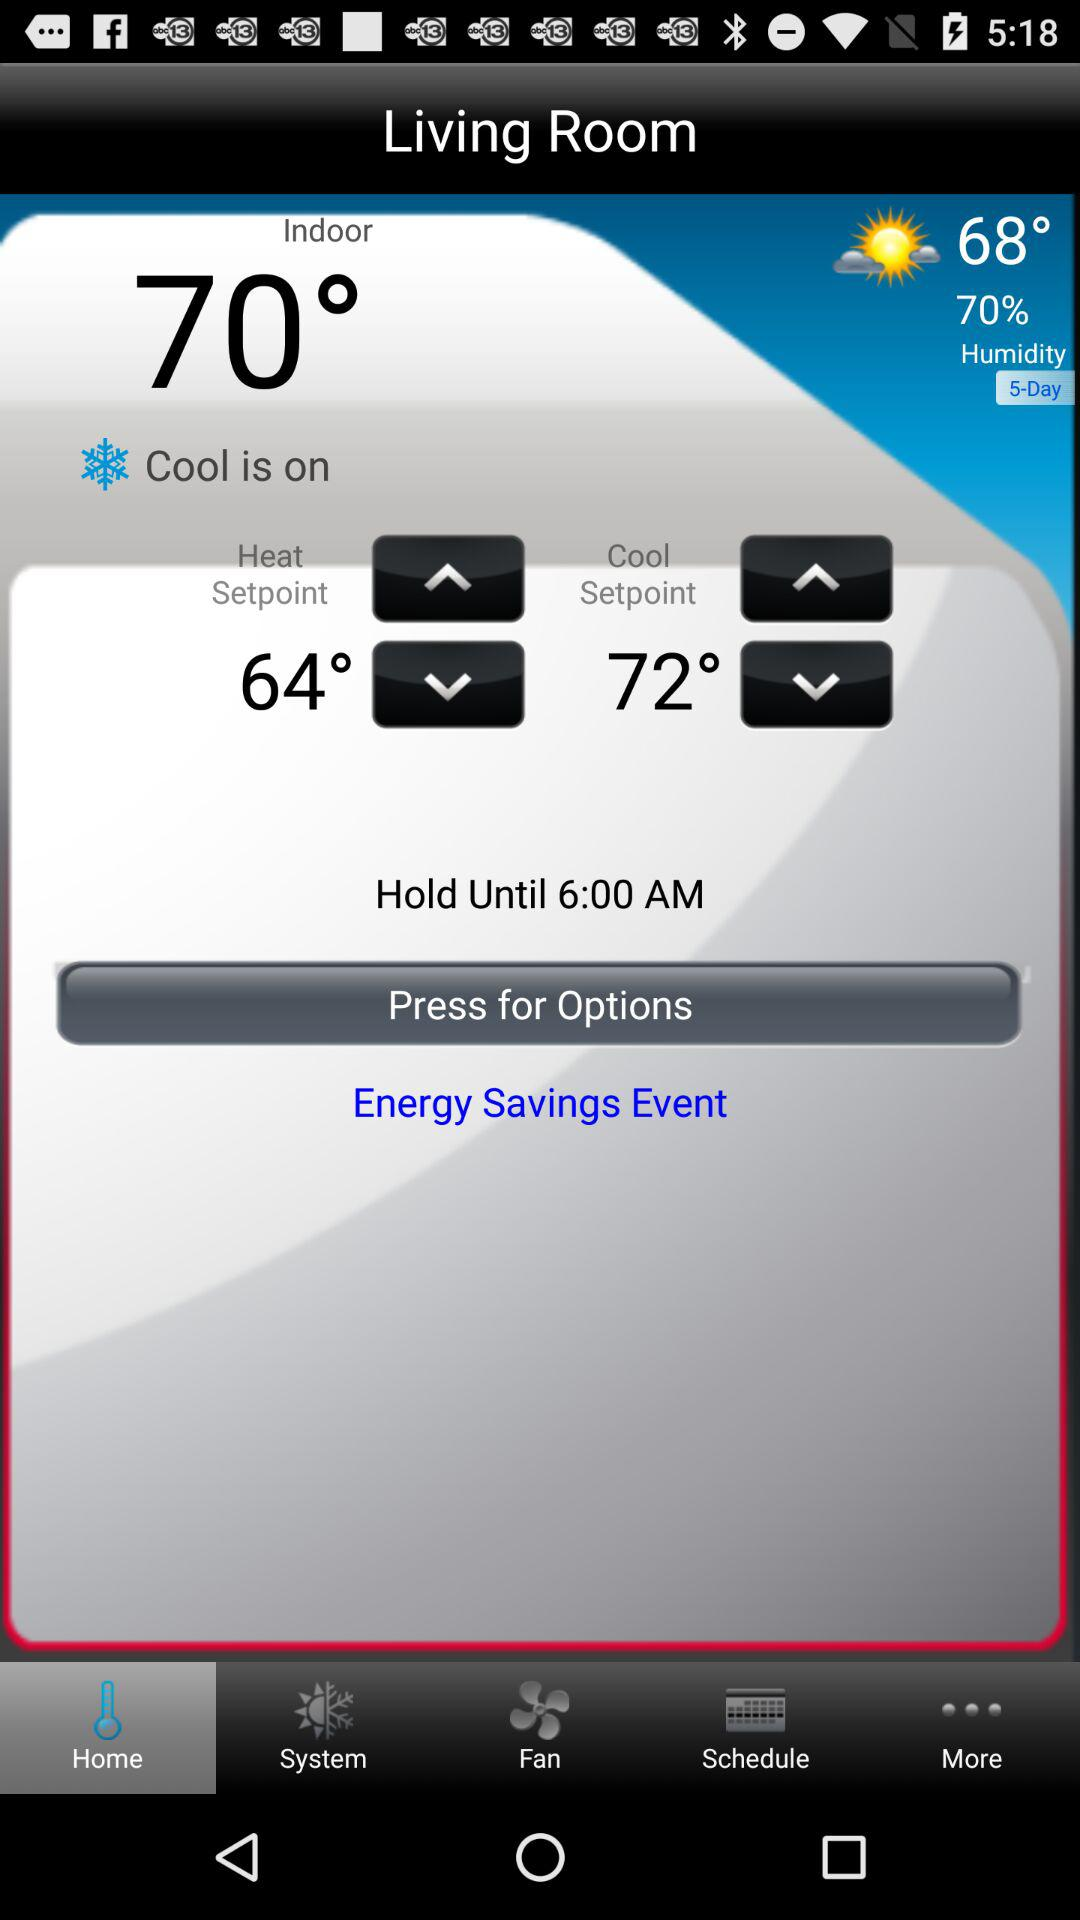What is the temperature outside? The temperature outside is 68°. 